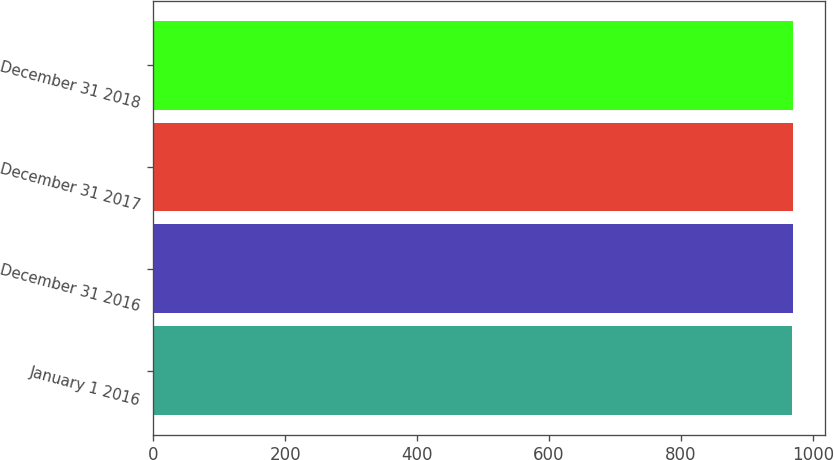Convert chart to OTSL. <chart><loc_0><loc_0><loc_500><loc_500><bar_chart><fcel>January 1 2016<fcel>December 31 2016<fcel>December 31 2017<fcel>December 31 2018<nl><fcel>969<fcel>969.1<fcel>969.2<fcel>969.3<nl></chart> 